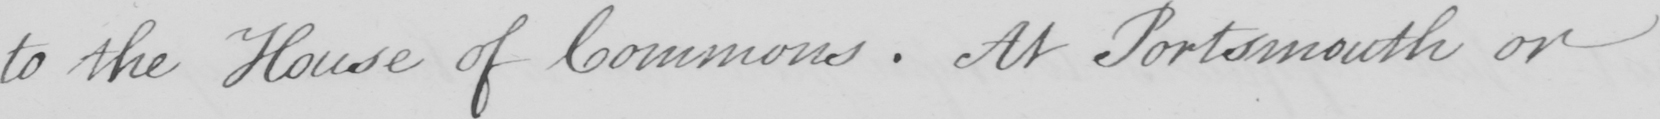What text is written in this handwritten line? to the House of Commons . At Portsmouth or 